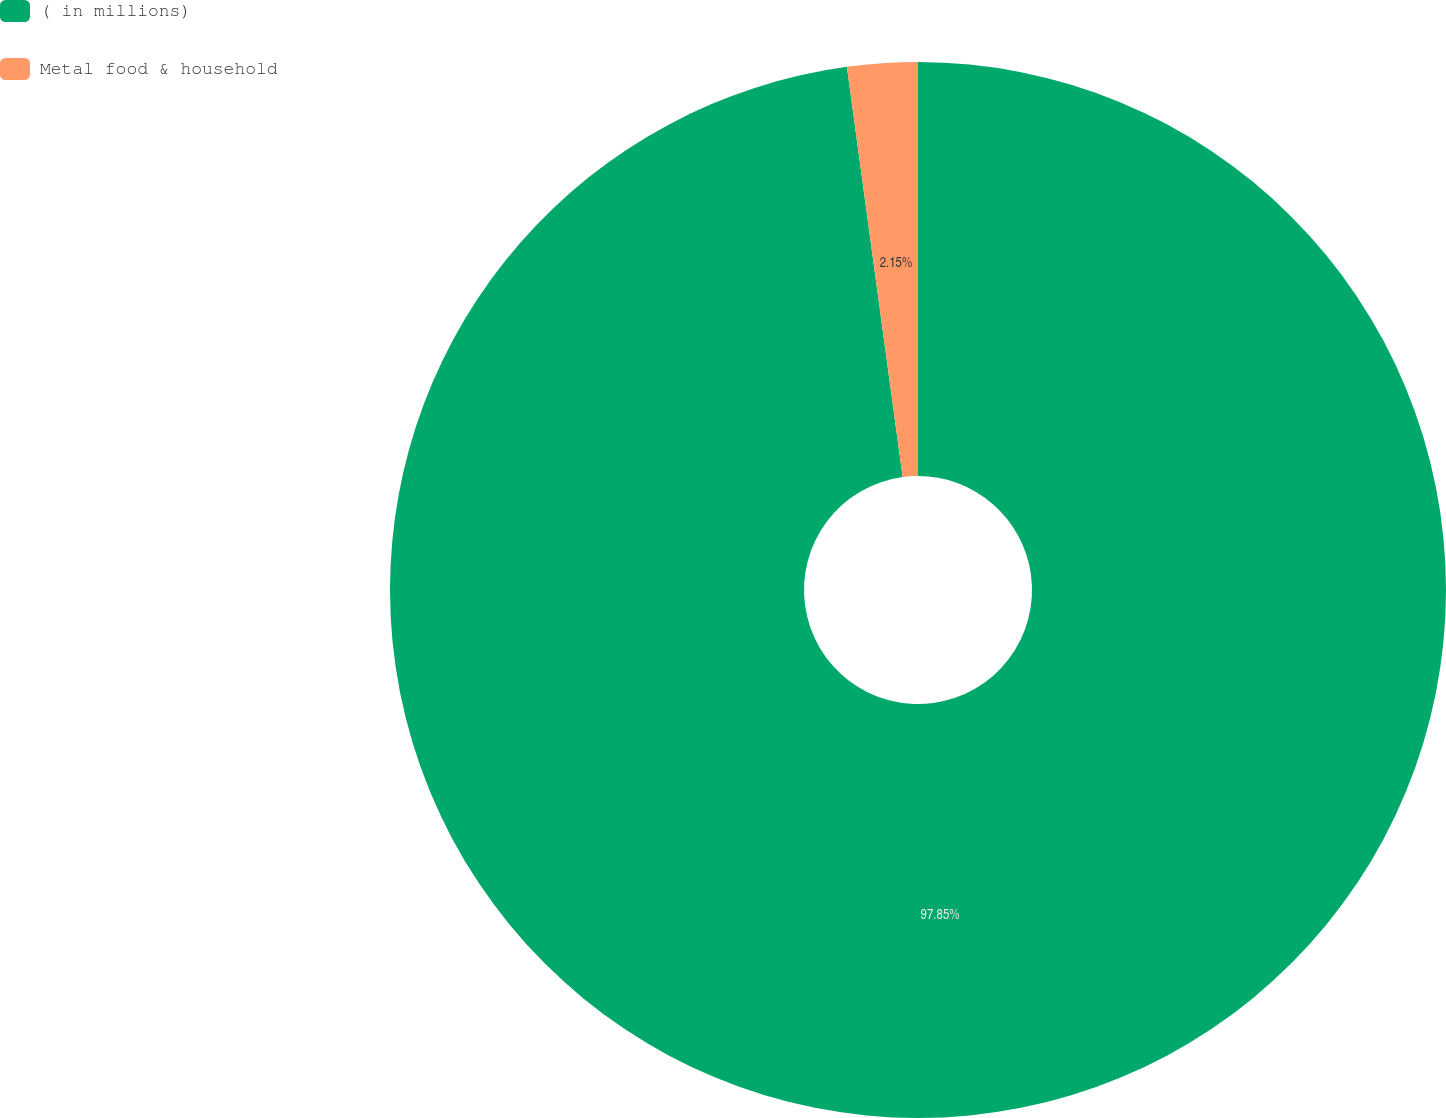Convert chart to OTSL. <chart><loc_0><loc_0><loc_500><loc_500><pie_chart><fcel>( in millions)<fcel>Metal food & household<nl><fcel>97.85%<fcel>2.15%<nl></chart> 